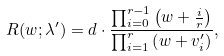Convert formula to latex. <formula><loc_0><loc_0><loc_500><loc_500>R ( w ; \lambda ^ { \prime } ) = d \cdot \frac { \prod _ { i = 0 } ^ { r - 1 } \left ( w + \frac { i } { r } \right ) } { \prod _ { i = 1 } ^ { r } \left ( w + v _ { i } ^ { \prime } \right ) } ,</formula> 